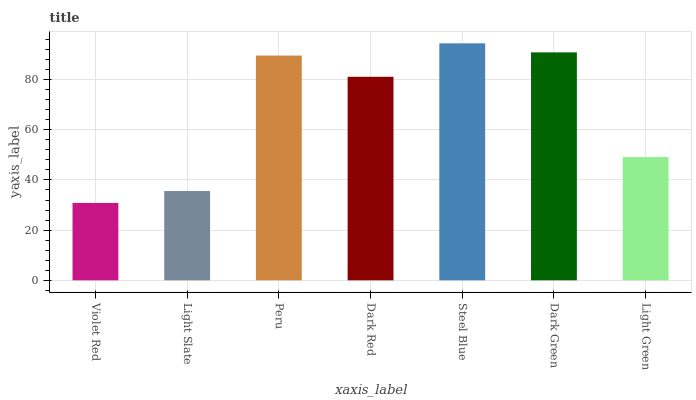Is Light Slate the minimum?
Answer yes or no. No. Is Light Slate the maximum?
Answer yes or no. No. Is Light Slate greater than Violet Red?
Answer yes or no. Yes. Is Violet Red less than Light Slate?
Answer yes or no. Yes. Is Violet Red greater than Light Slate?
Answer yes or no. No. Is Light Slate less than Violet Red?
Answer yes or no. No. Is Dark Red the high median?
Answer yes or no. Yes. Is Dark Red the low median?
Answer yes or no. Yes. Is Light Slate the high median?
Answer yes or no. No. Is Violet Red the low median?
Answer yes or no. No. 